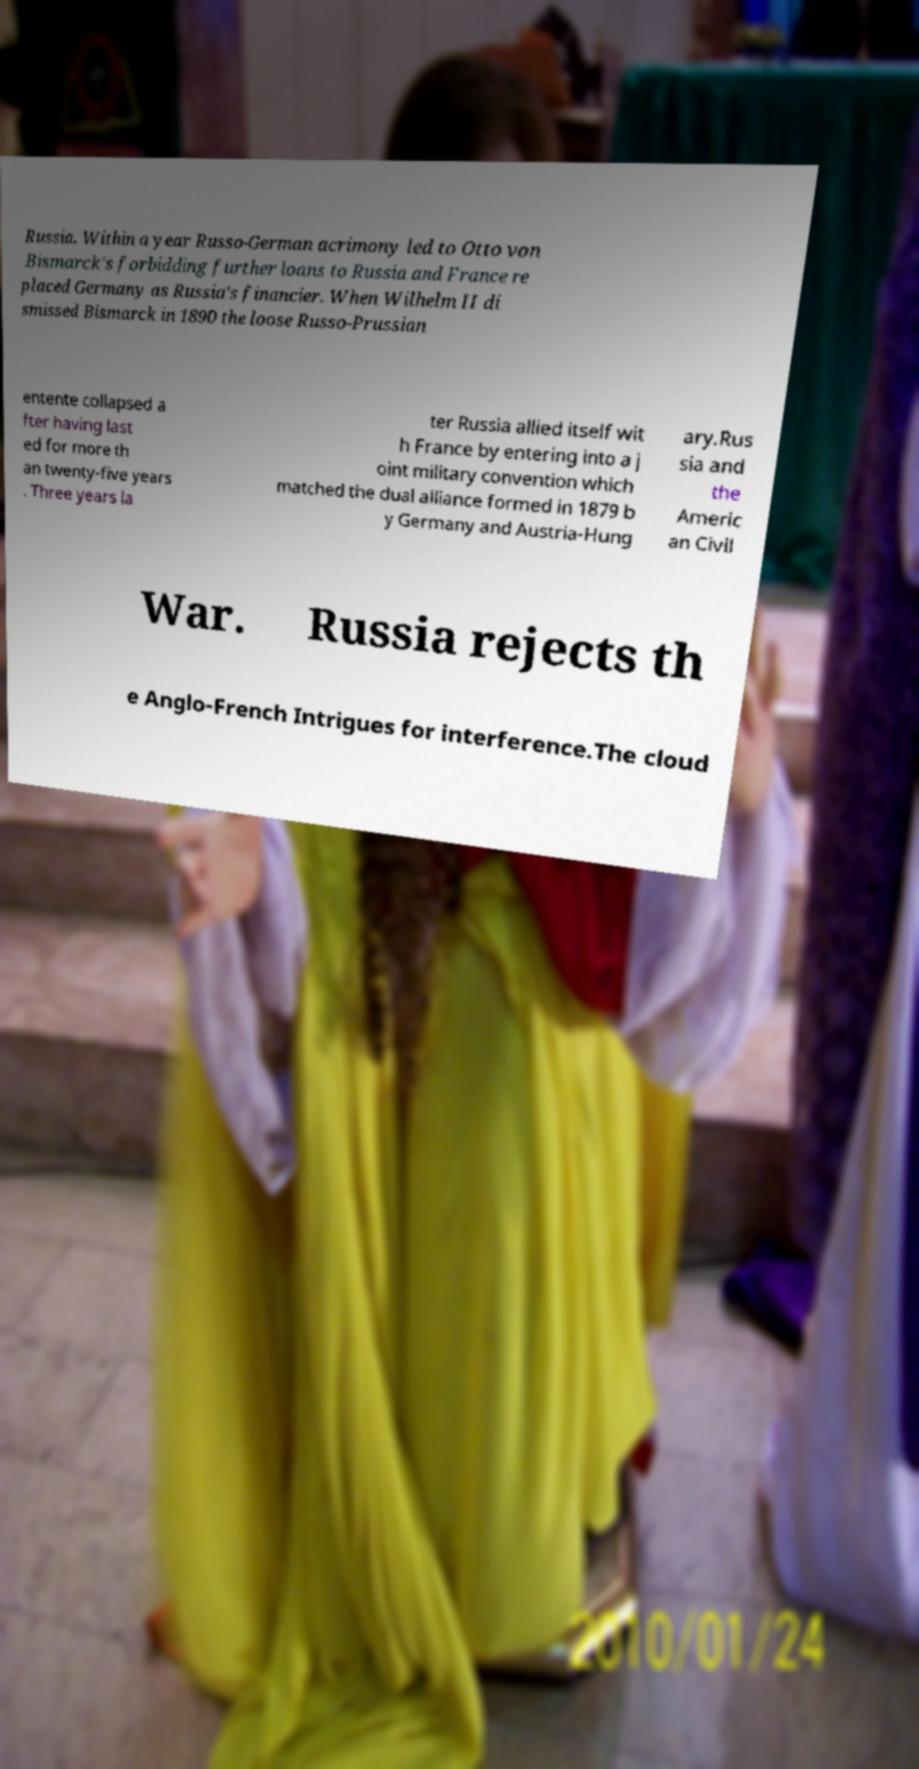For documentation purposes, I need the text within this image transcribed. Could you provide that? Russia. Within a year Russo-German acrimony led to Otto von Bismarck's forbidding further loans to Russia and France re placed Germany as Russia's financier. When Wilhelm II di smissed Bismarck in 1890 the loose Russo-Prussian entente collapsed a fter having last ed for more th an twenty-five years . Three years la ter Russia allied itself wit h France by entering into a j oint military convention which matched the dual alliance formed in 1879 b y Germany and Austria-Hung ary.Rus sia and the Americ an Civil War. Russia rejects th e Anglo-French Intrigues for interference.The cloud 